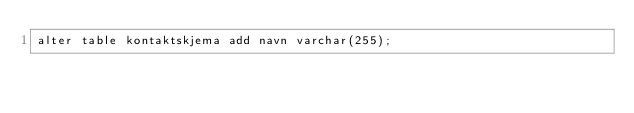<code> <loc_0><loc_0><loc_500><loc_500><_SQL_>alter table kontaktskjema add navn varchar(255);</code> 